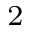Convert formula to latex. <formula><loc_0><loc_0><loc_500><loc_500>^ { 2 }</formula> 